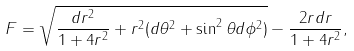Convert formula to latex. <formula><loc_0><loc_0><loc_500><loc_500>F = \sqrt { \frac { d r ^ { 2 } } { 1 + 4 r ^ { 2 } } + r ^ { 2 } ( d \theta ^ { 2 } + \sin ^ { 2 } \theta d \phi ^ { 2 } ) } - \frac { 2 r d r } { 1 + 4 r ^ { 2 } } ,</formula> 